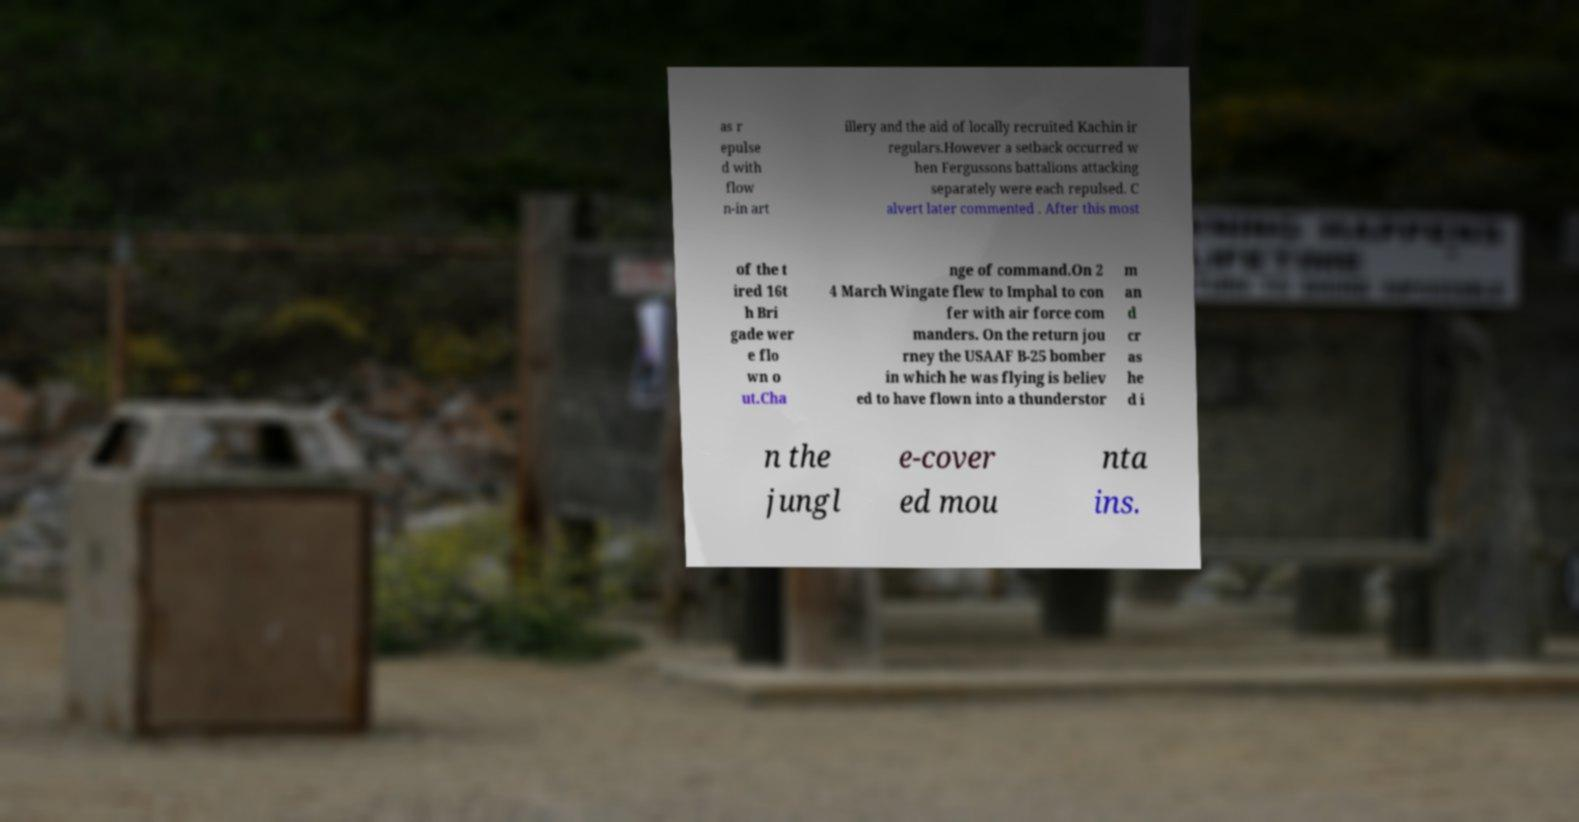Can you read and provide the text displayed in the image?This photo seems to have some interesting text. Can you extract and type it out for me? as r epulse d with flow n-in art illery and the aid of locally recruited Kachin ir regulars.However a setback occurred w hen Fergussons battalions attacking separately were each repulsed. C alvert later commented . After this most of the t ired 16t h Bri gade wer e flo wn o ut.Cha nge of command.On 2 4 March Wingate flew to Imphal to con fer with air force com manders. On the return jou rney the USAAF B-25 bomber in which he was flying is believ ed to have flown into a thunderstor m an d cr as he d i n the jungl e-cover ed mou nta ins. 